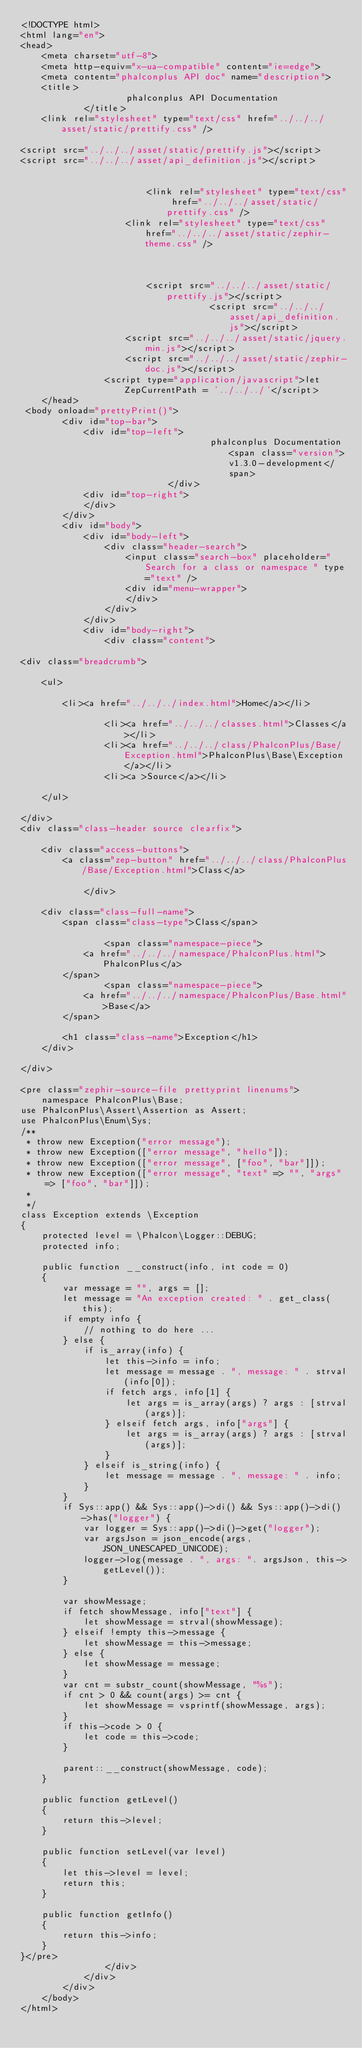<code> <loc_0><loc_0><loc_500><loc_500><_HTML_><!DOCTYPE html>
<html lang="en">
<head>
    <meta charset="utf-8">
    <meta http-equiv="x-ua-compatible" content="ie=edge">
    <meta content="phalconplus API doc" name="description">
    <title>
                    phalconplus API Documentation
            </title>
    <link rel="stylesheet" type="text/css" href="../../../asset/static/prettify.css" />

<script src="../../../asset/static/prettify.js"></script>
<script src="../../../asset/api_definition.js"></script>


                        <link rel="stylesheet" type="text/css" href="../../../asset/static/prettify.css" />
                    <link rel="stylesheet" type="text/css" href="../../../asset/static/zephir-theme.css" />
            
    

                        <script src="../../../asset/static/prettify.js"></script>
                                    <script src="../../../asset/api_definition.js"></script>
                    <script src="../../../asset/static/jquery.min.js"></script>
                    <script src="../../../asset/static/zephir-doc.js"></script>
                <script type="application/javascript">let ZepCurrentPath = '../../../'</script>
    </head>
 <body onload="prettyPrint()">
        <div id="top-bar">
            <div id="top-left">
                                    phalconplus Documentation <span class="version">v1.3.0-development</span>
                            </div>
            <div id="top-right">
            </div>
        </div>
        <div id="body">
            <div id="body-left">
                <div class="header-search">
                    <input class="search-box" placeholder="Search for a class or namespace " type="text" />
                    <div id="menu-wrapper">
                    </div>
                </div>
            </div>
            <div id="body-right">
                <div class="content">
                    
<div class="breadcrumb">
    
    <ul>
        
        <li><a href="../../../index.html">Home</a></li>
        
                <li><a href="../../../classes.html">Classes</a></li>
                <li><a href="../../../class/PhalconPlus/Base/Exception.html">PhalconPlus\Base\Exception</a></li>
                <li><a >Source</a></li>
                
    </ul>
    
</div>
<div class="class-header source clearfix">
    
    <div class="access-buttons">
        <a class="zep-button" href="../../../class/PhalconPlus/Base/Exception.html">Class</a>

            </div>
    
    <div class="class-full-name">
        <span class="class-type">Class</span>
        
                <span class="namespace-piece">
            <a href="../../../namespace/PhalconPlus.html">PhalconPlus</a>
        </span>
                <span class="namespace-piece">
            <a href="../../../namespace/PhalconPlus/Base.html">Base</a>
        </span>
        
        <h1 class="class-name">Exception</h1>
    </div>
    
</div>

<pre class="zephir-source-file prettyprint linenums">
    namespace PhalconPlus\Base;
use PhalconPlus\Assert\Assertion as Assert;
use PhalconPlus\Enum\Sys;
/**
 * throw new Exception("error message");
 * throw new Exception(["error message", "hello"]);
 * throw new Exception(["error message", ["foo", "bar"]]);
 * throw new Exception(["error message", "text" => "", "args" => ["foo", "bar"]]);
 *
 */
class Exception extends \Exception
{
    protected level = \Phalcon\Logger::DEBUG;
    protected info;

    public function __construct(info, int code = 0)
    {
        var message = "", args = [];
        let message = "An exception created: " . get_class(this);
        if empty info {
            // nothing to do here ...
        } else {
            if is_array(info) {
                let this->info = info;
                let message = message . ", message: " . strval(info[0]);
                if fetch args, info[1] {
                    let args = is_array(args) ? args : [strval(args)];
                } elseif fetch args, info["args"] {
                    let args = is_array(args) ? args : [strval(args)];
                }
            } elseif is_string(info) {
                let message = message . ", message: " . info;
            }
        }
        if Sys::app() && Sys::app()->di() && Sys::app()->di()->has("logger") {
            var logger = Sys::app()->di()->get("logger");
            var argsJson = json_encode(args, JSON_UNESCAPED_UNICODE);
            logger->log(message . ", args: ". argsJson, this->getLevel());
        }

        var showMessage;
        if fetch showMessage, info["text"] {
            let showMessage = strval(showMessage);
        } elseif !empty this->message {
            let showMessage = this->message;
        } else {
            let showMessage = message;
        }
        var cnt = substr_count(showMessage, "%s");
        if cnt > 0 && count(args) >= cnt {
            let showMessage = vsprintf(showMessage, args);
        }
        if this->code > 0 {
            let code = this->code;
        }
        
        parent::__construct(showMessage, code);
    }

    public function getLevel()
    {
        return this->level;
    }

    public function setLevel(var level)
    {
        let this->level = level;
        return this;
    }

    public function getInfo()
    {
        return this->info;
    }
}</pre>
                </div>
            </div>
        </div>
    </body>
</html>
</code> 